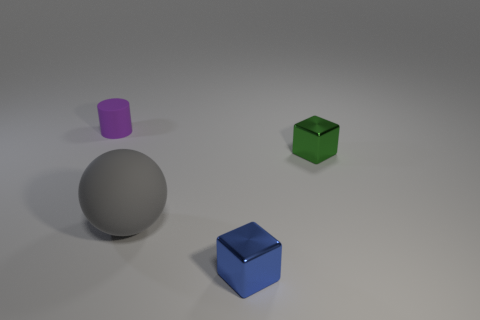Add 2 matte objects. How many objects exist? 6 Subtract 0 cyan balls. How many objects are left? 4 Subtract all spheres. How many objects are left? 3 Subtract 1 spheres. How many spheres are left? 0 Subtract all green blocks. Subtract all red cylinders. How many blocks are left? 1 Subtract all blue blocks. How many red spheres are left? 0 Subtract all tiny purple metal blocks. Subtract all gray rubber balls. How many objects are left? 3 Add 2 small green metallic things. How many small green metallic things are left? 3 Add 4 green metal cubes. How many green metal cubes exist? 5 Subtract all green cubes. How many cubes are left? 1 